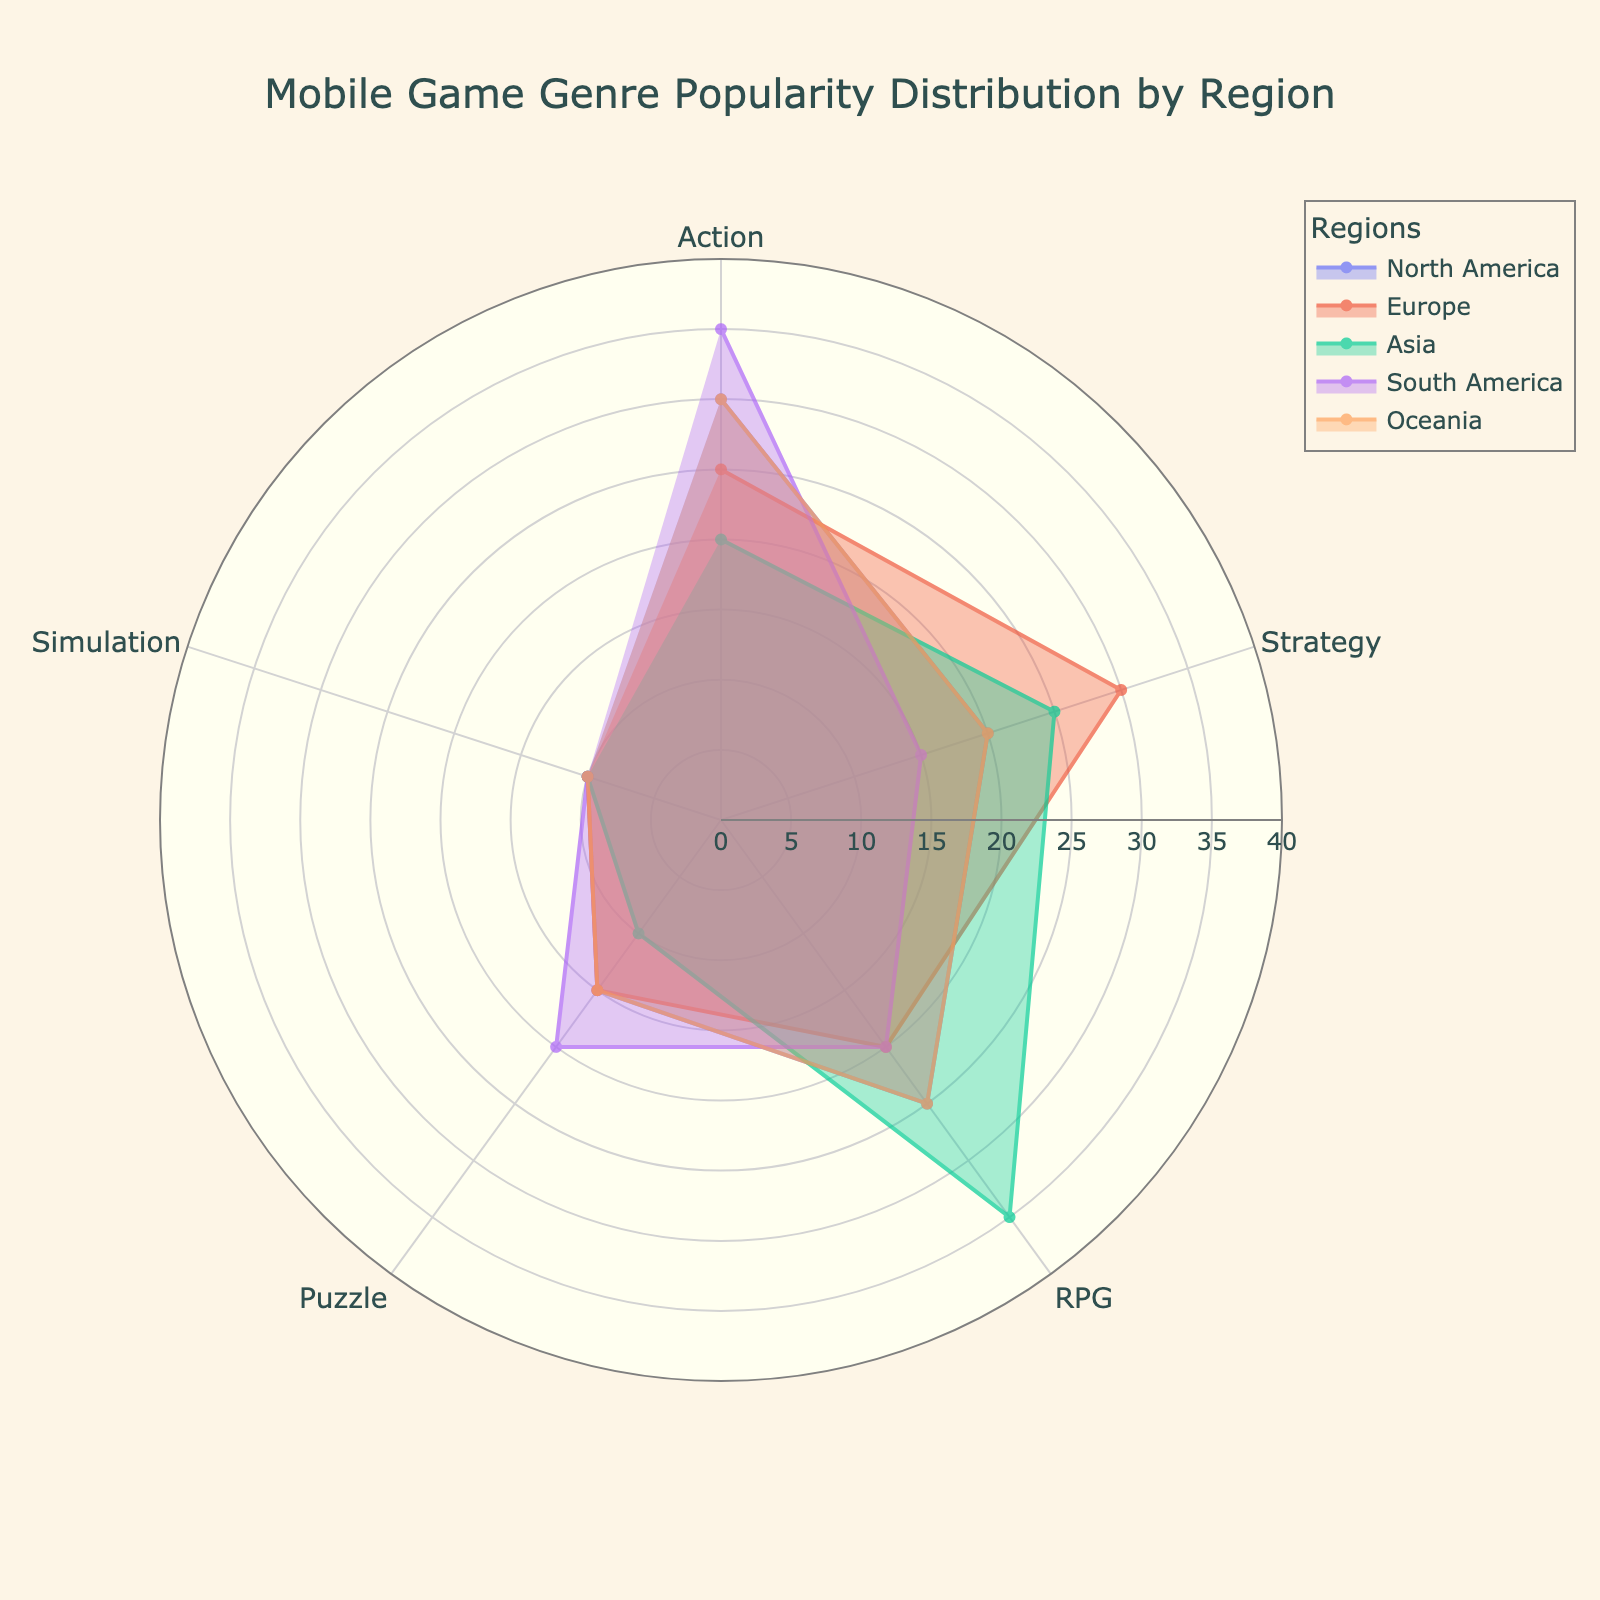What is the title of the figure? The title is usually found at the top of the figure and is meant to provide a clear indicator of what the visual data represents. In this case, it mentions both the subject (Mobile Game Genre) and the comparison basis (Region).
Answer: Mobile Game Genre Popularity Distribution by Region Which region has the highest popularity for Action games? By locating the segments labeled "Action" for each region, we can compare their lengths. The longest segment will correspond to the region with the highest popularity in that genre.
Answer: South America What is the range of the radial axis? The radial axis on a polar area chart helps determine the extent of the data. We look for the labels indicating the minimum and maximum values provided on the radial axis.
Answer: 0 to 40 Which genre is the most popular in Asia? To find this, observe the segments corresponding to Asia and look for the genre with the longest segment. Evaluating the visibility and length of segments allows us to determine popularity.
Answer: RPG Compare the popularity of Strategy games in North America and Europe. Which region has a higher popularity? Comparing the sizes of the "Strategy" segments for North America and Europe reveals which region has a larger segment, indicating greater popularity.
Answer: Europe What is the least popular mobile game genre in South America? Identify the genre with the shortest segment in the South America region to determine the least popular genre.
Answer: Simulation Calculate the average popularity for Puzzle games across all regions. First, note the values for Puzzle games in each region: North America (15), Europe (15), Asia (10), South America (20), and Oceania (15). Adding these values and dividing by the number of regions gives us the average. Calculation: (15 + 15 + 10 + 20 + 15) / 5 = 15.
Answer: 15 Which two genres have the same popularity value in North America? Look for segments in North America that extend to the same distance from the center, indicating equal popularity values.
Answer: Puzzle and Simulation What is the popularity difference between RPG games in North America and Asia? Locate the RPG segments for North America (25) and Asia (35) and compute their difference. Calculation: 35 - 25 = 10.
Answer: 10 In which region is the popularity of Simulation games identical? We need to check the Simulation segments for South America, Asia, and Oceania to see if their lengths match, indicating identical popularity.
Answer: Asia and South America 